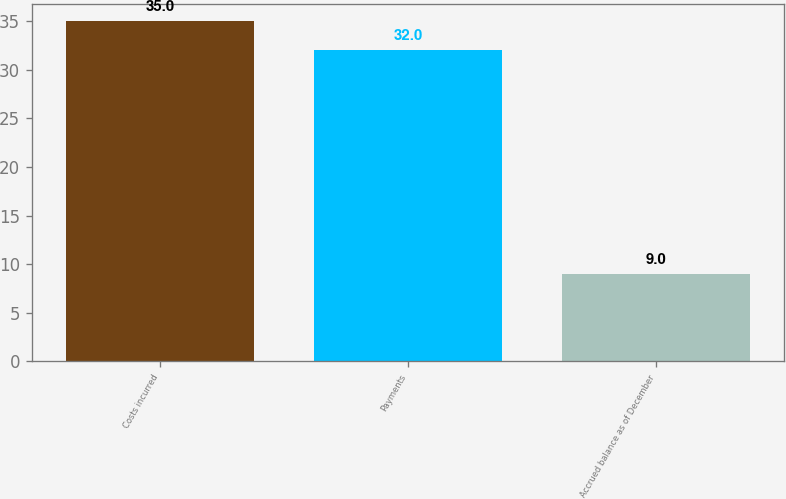Convert chart. <chart><loc_0><loc_0><loc_500><loc_500><bar_chart><fcel>Costs incurred<fcel>Payments<fcel>Accrued balance as of December<nl><fcel>35<fcel>32<fcel>9<nl></chart> 